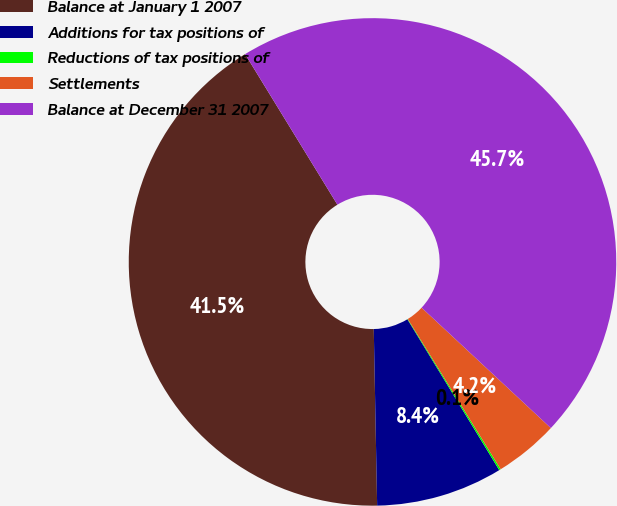<chart> <loc_0><loc_0><loc_500><loc_500><pie_chart><fcel>Balance at January 1 2007<fcel>Additions for tax positions of<fcel>Reductions of tax positions of<fcel>Settlements<fcel>Balance at December 31 2007<nl><fcel>41.55%<fcel>8.4%<fcel>0.11%<fcel>4.25%<fcel>45.69%<nl></chart> 